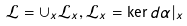Convert formula to latex. <formula><loc_0><loc_0><loc_500><loc_500>\mathcal { L } = \cup _ { x } \mathcal { L } _ { x } , \mathcal { L } _ { x } = \ker d \alpha | _ { x }</formula> 